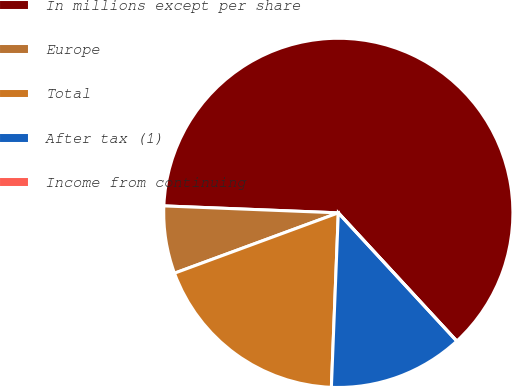Convert chart to OTSL. <chart><loc_0><loc_0><loc_500><loc_500><pie_chart><fcel>In millions except per share<fcel>Europe<fcel>Total<fcel>After tax (1)<fcel>Income from continuing<nl><fcel>62.49%<fcel>6.25%<fcel>18.75%<fcel>12.5%<fcel>0.0%<nl></chart> 